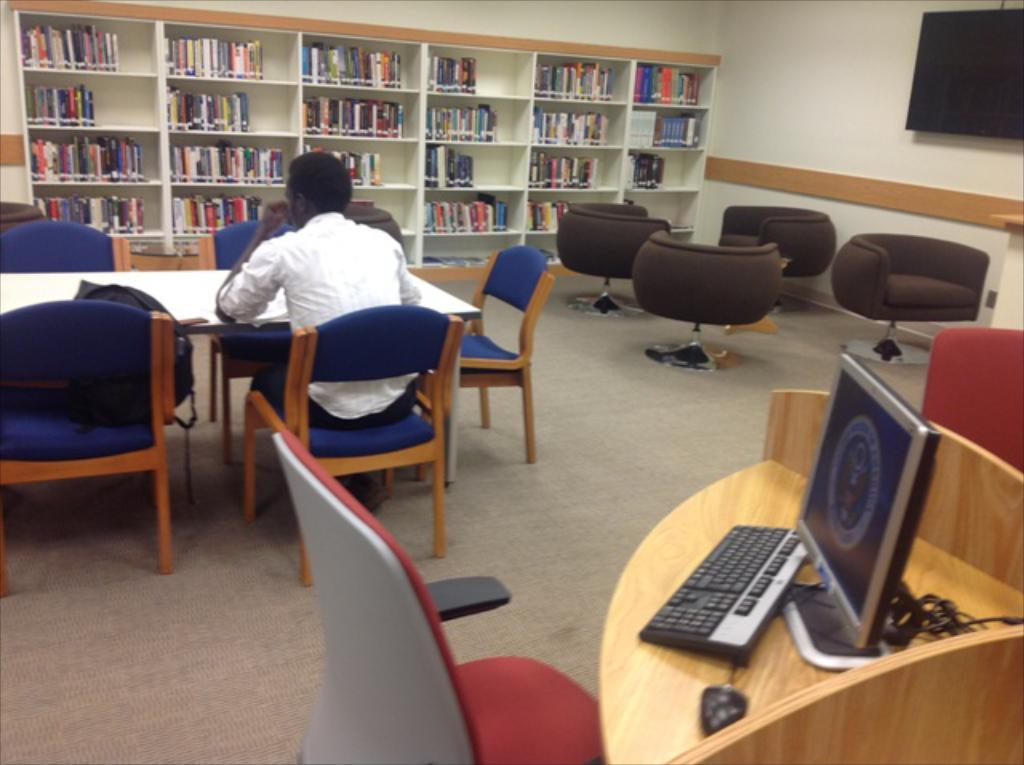What color is the chair that the person is sitting on? The person is sitting in a blue chair. What is in front of the person? There is a table and a bookshelf in front of the person. Where is the television located in the image? The television is in the right corner of the image. What type of fuel is being used by the tooth in the image? There is no tooth present in the image, and therefore no fuel is being used. 